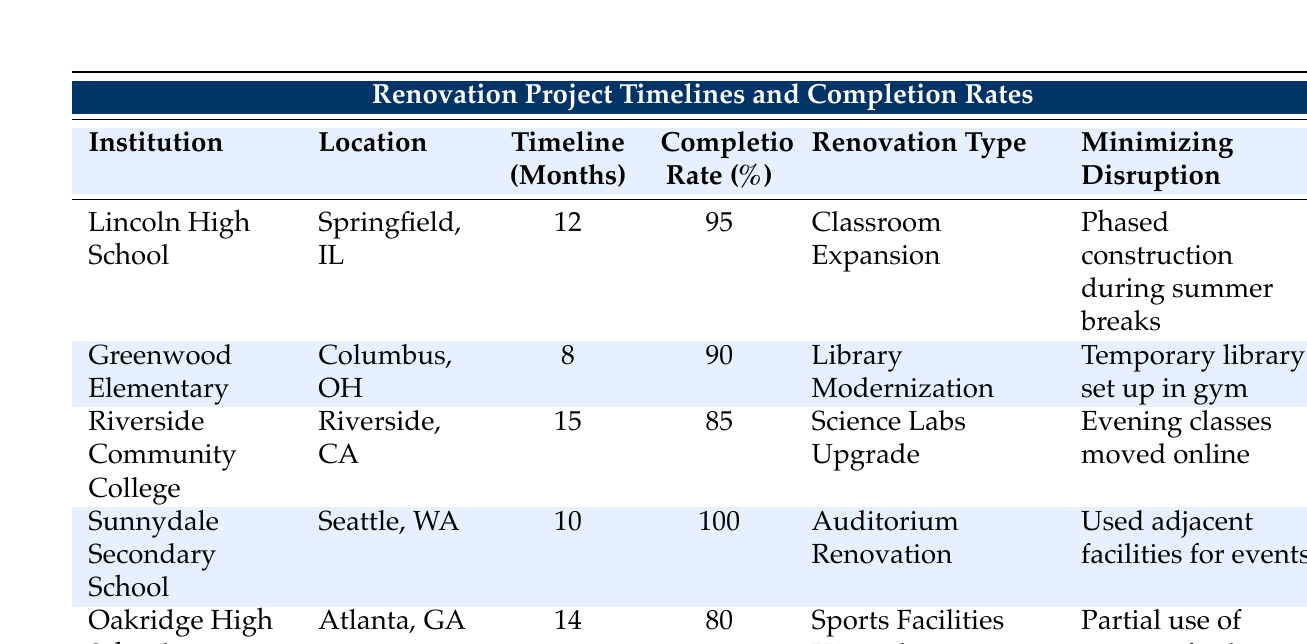What is the completion rate for Lincoln High School? The table lists Lincoln High School under the "Completion Rate" column and shows the value as 95%.
Answer: 95% Which institution had the longest renovation timeline? By comparing the "Timeline (Months)" for each institution, Riverside Community College has the highest value of 15 months.
Answer: Riverside Community College What is the average completion rate for all projects? To find the average, add the completion rates: 95 + 90 + 85 + 100 + 80 = 450. Then divide by the number of institutions (5): 450/5 = 90.
Answer: 90 Did Sunnydale Secondary School finish ahead of schedule? The notes for Sunnydale Secondary School indicate that it was "fully completed ahead of schedule," confirming a yes.
Answer: Yes How many institutions had a completion rate greater than 90%? By examining the completion rates: Lincoln High School (95%), Greenwood Elementary (90%), and Sunnydale Secondary School (100%), only Lincoln and Sunnydale exceed 90%. Thus, there are 2 institutions.
Answer: 2 Which renovation type had the shortest timeline? Looking at the "Timeline (Months)" column, Greenwood Elementary's Library Modernization took 8 months, the shortest duration of all listed projects.
Answer: Library Modernization Was there a project with a 100% completion rate? The table clearly states that Sunnydale Secondary School had a 100% completion rate, confirming a yes.
Answer: Yes What is the difference in completion rates between Oakridge High School and Sunnydale Secondary School? The completion rate for Oakridge High School is 80%, and for Sunnydale Secondary School, it is 100%. The difference is 100 - 80 = 20%.
Answer: 20% How many projects minimized disruption by moving classes online? By reviewing the "Minimizing Disruption" column, only Riverside Community College moved classes online, indicating 1 project.
Answer: 1 